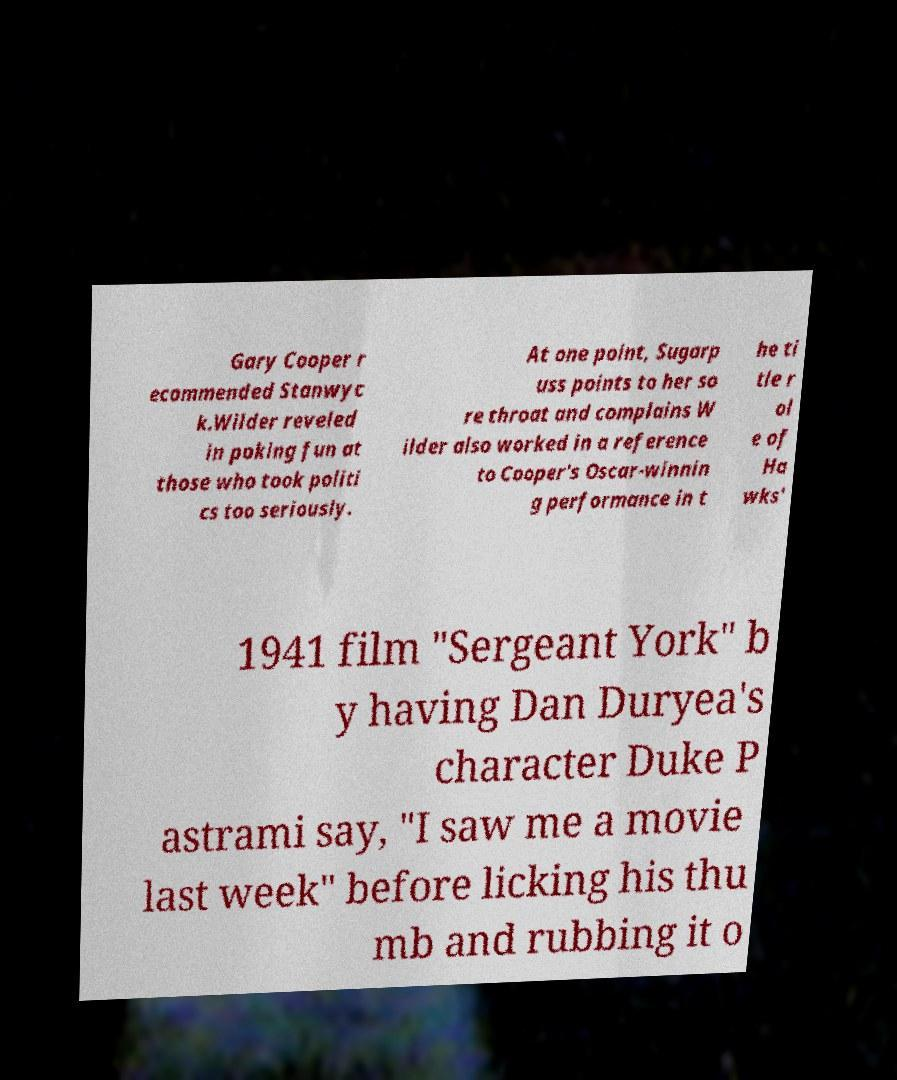Could you assist in decoding the text presented in this image and type it out clearly? Gary Cooper r ecommended Stanwyc k.Wilder reveled in poking fun at those who took politi cs too seriously. At one point, Sugarp uss points to her so re throat and complains W ilder also worked in a reference to Cooper's Oscar-winnin g performance in t he ti tle r ol e of Ha wks' 1941 film "Sergeant York" b y having Dan Duryea's character Duke P astrami say, "I saw me a movie last week" before licking his thu mb and rubbing it o 